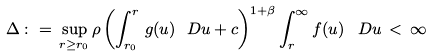Convert formula to latex. <formula><loc_0><loc_0><loc_500><loc_500>\Delta \, \colon = \, \sup _ { r \geq r _ { 0 } } \rho \left ( \int _ { r _ { 0 } } ^ { r } \, g ( u ) \ D u + c \right ) ^ { 1 + \beta } \int _ { r } ^ { \infty } f ( u ) \, \ D u \, < \, \infty</formula> 